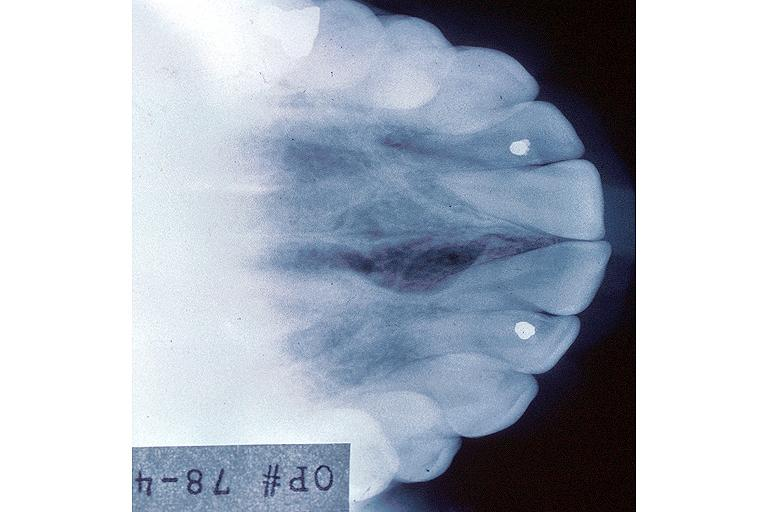s endocervical polyp present?
Answer the question using a single word or phrase. No 